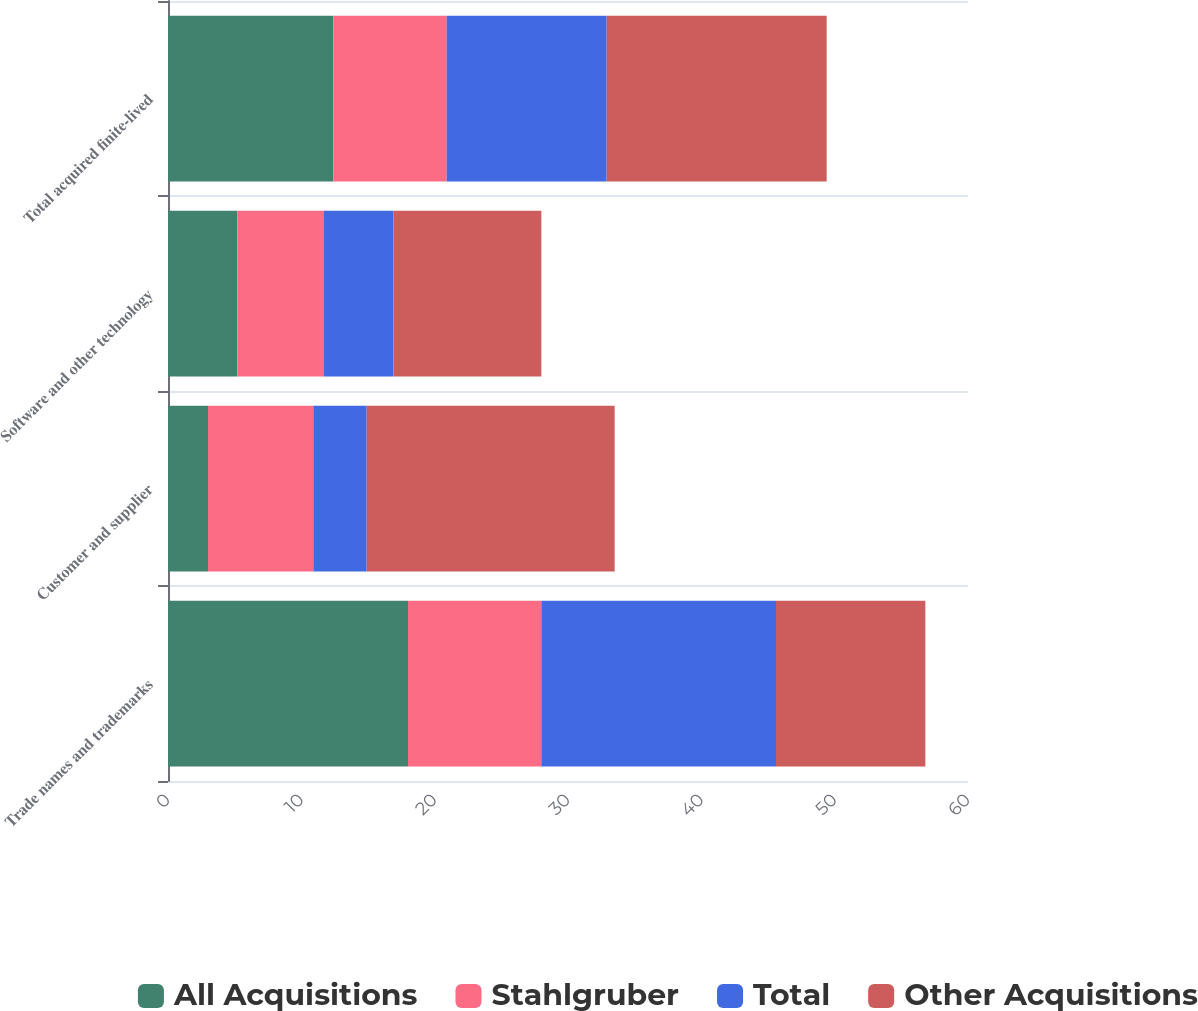Convert chart. <chart><loc_0><loc_0><loc_500><loc_500><stacked_bar_chart><ecel><fcel>Trade names and trademarks<fcel>Customer and supplier<fcel>Software and other technology<fcel>Total acquired finite-lived<nl><fcel>All Acquisitions<fcel>18<fcel>3<fcel>5.2<fcel>12.4<nl><fcel>Stahlgruber<fcel>10<fcel>7.9<fcel>6.5<fcel>8.5<nl><fcel>Total<fcel>17.6<fcel>4<fcel>5.2<fcel>12<nl><fcel>Other Acquisitions<fcel>11.2<fcel>18.6<fcel>11.1<fcel>16.5<nl></chart> 